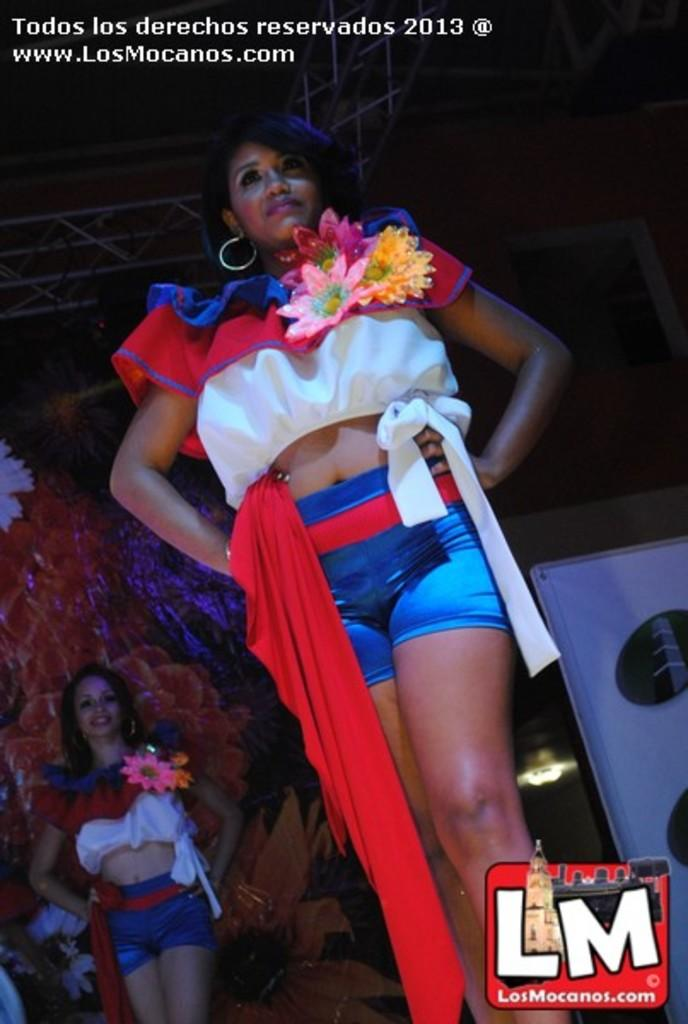<image>
Render a clear and concise summary of the photo. A woman in a red/white top and blue shorts with hands on hip and in the lower right corner there's a logo for "losmocanos.com" 